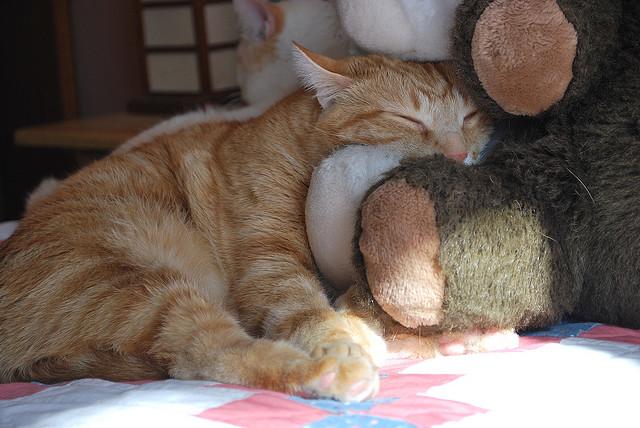What is laying on the cat?
Be succinct. Teddy bear. Is the person using their left or right hand?
Quick response, please. Neither. Is the cat sleepy?
Write a very short answer. Yes. Does the cat look happy?
Keep it brief. Yes. Is this cat wearing a collar?
Write a very short answer. No. What is the cat laying on?
Short answer required. Bed. Is the cat awake?
Keep it brief. No. What number is the ear touching?
Concise answer only. 0. Are the cats being playful or aggressive?
Concise answer only. Playful. What colors are in the blanket?
Write a very short answer. White pink and blue. 